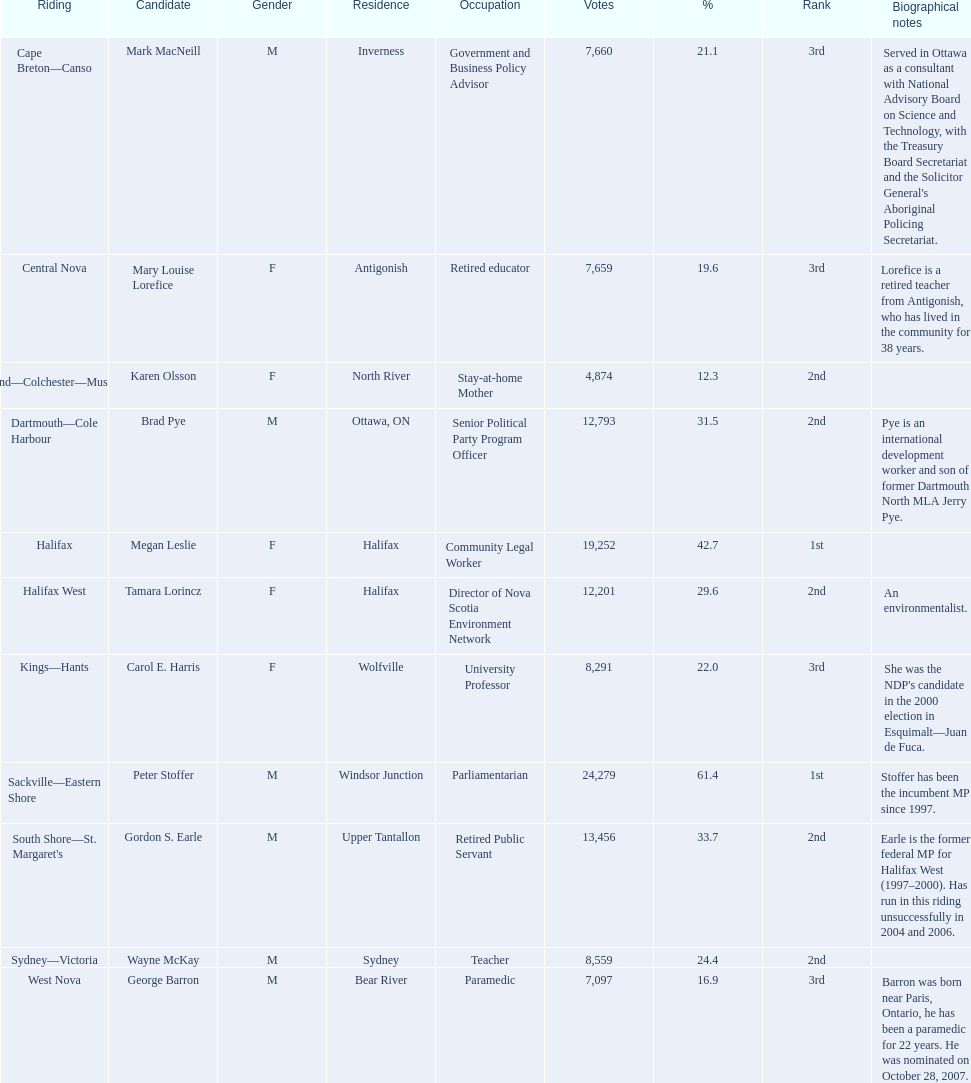How many candidates were from halifax? 2. 